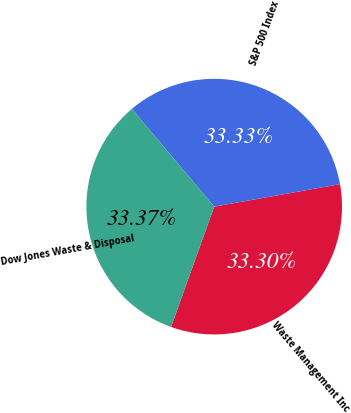<chart> <loc_0><loc_0><loc_500><loc_500><pie_chart><fcel>Waste Management Inc<fcel>S&P 500 Index<fcel>Dow Jones Waste & Disposal<nl><fcel>33.3%<fcel>33.33%<fcel>33.37%<nl></chart> 